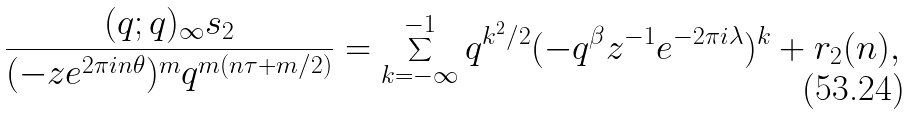<formula> <loc_0><loc_0><loc_500><loc_500>\frac { ( q ; q ) _ { \infty } s _ { 2 } } { ( - z e ^ { 2 \pi i n \theta } ) ^ { m } q ^ { m ( n \tau + m / 2 ) } } = \sum _ { k = - \infty } ^ { - 1 } q ^ { k ^ { 2 } / 2 } ( - q ^ { \beta } z ^ { - 1 } e ^ { - 2 \pi i \lambda } ) ^ { k } + r _ { 2 } ( n ) ,</formula> 